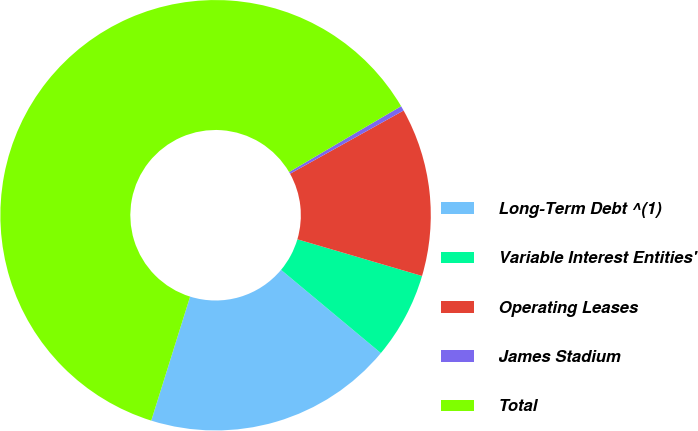Convert chart to OTSL. <chart><loc_0><loc_0><loc_500><loc_500><pie_chart><fcel>Long-Term Debt ^(1)<fcel>Variable Interest Entities'<fcel>Operating Leases<fcel>James Stadium<fcel>Total<nl><fcel>18.77%<fcel>6.51%<fcel>12.64%<fcel>0.37%<fcel>61.71%<nl></chart> 